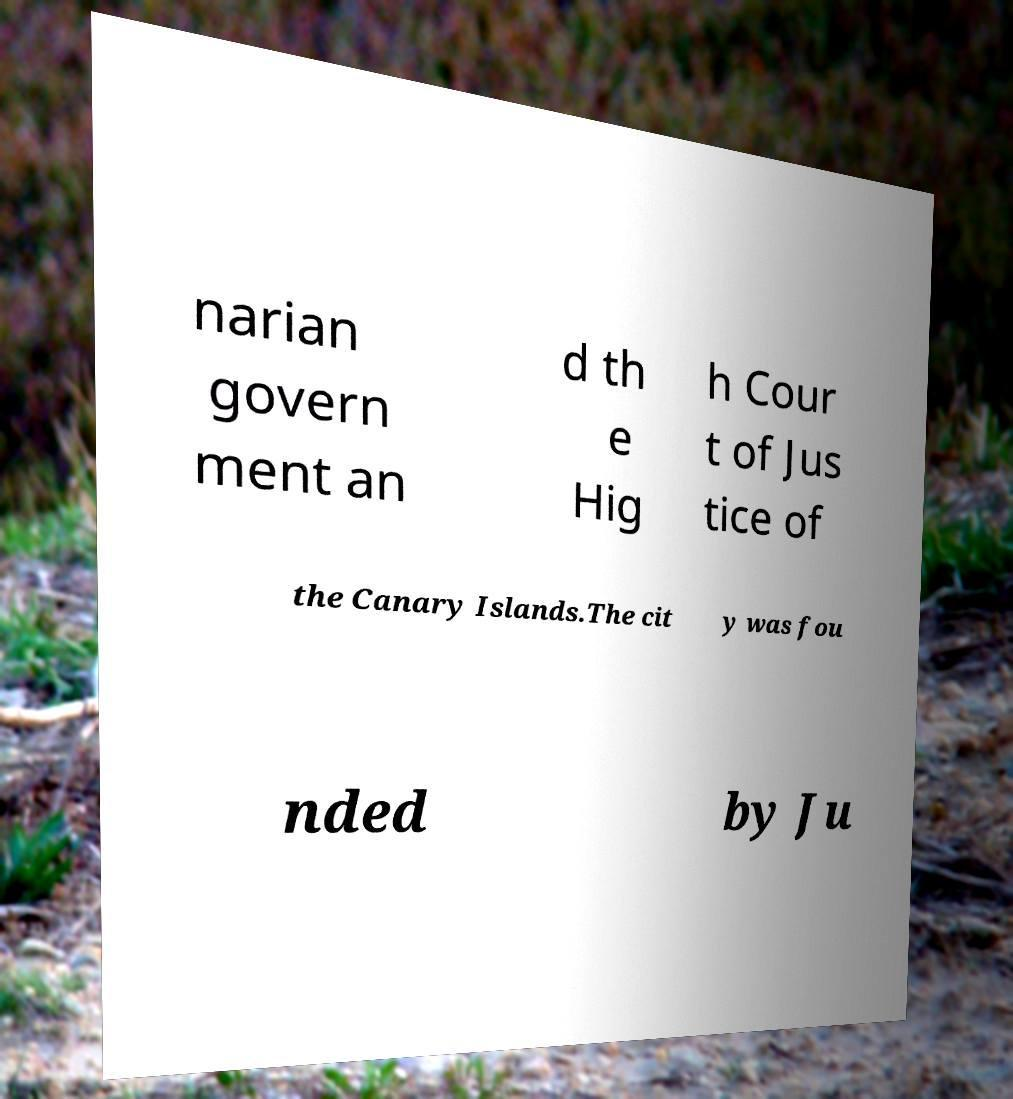There's text embedded in this image that I need extracted. Can you transcribe it verbatim? narian govern ment an d th e Hig h Cour t of Jus tice of the Canary Islands.The cit y was fou nded by Ju 